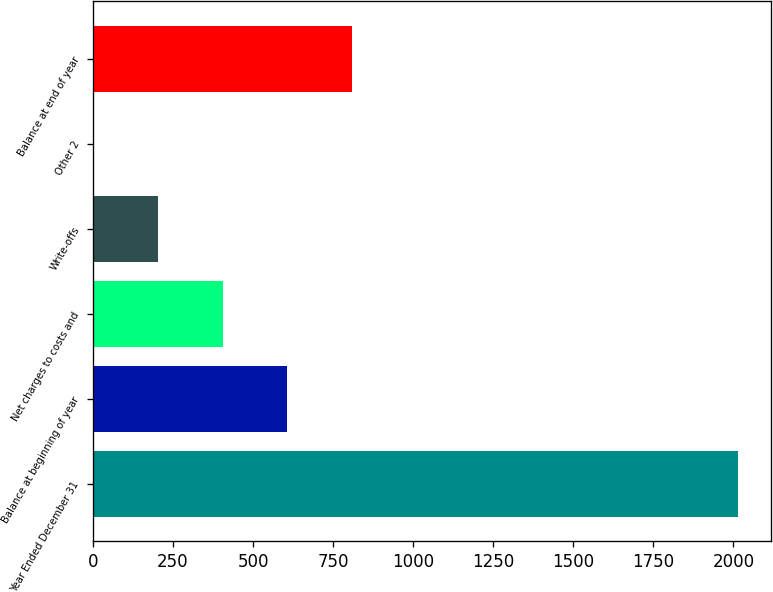Convert chart. <chart><loc_0><loc_0><loc_500><loc_500><bar_chart><fcel>Year Ended December 31<fcel>Balance at beginning of year<fcel>Net charges to costs and<fcel>Write-offs<fcel>Other 2<fcel>Balance at end of year<nl><fcel>2016<fcel>606.2<fcel>404.8<fcel>203.4<fcel>2<fcel>807.6<nl></chart> 